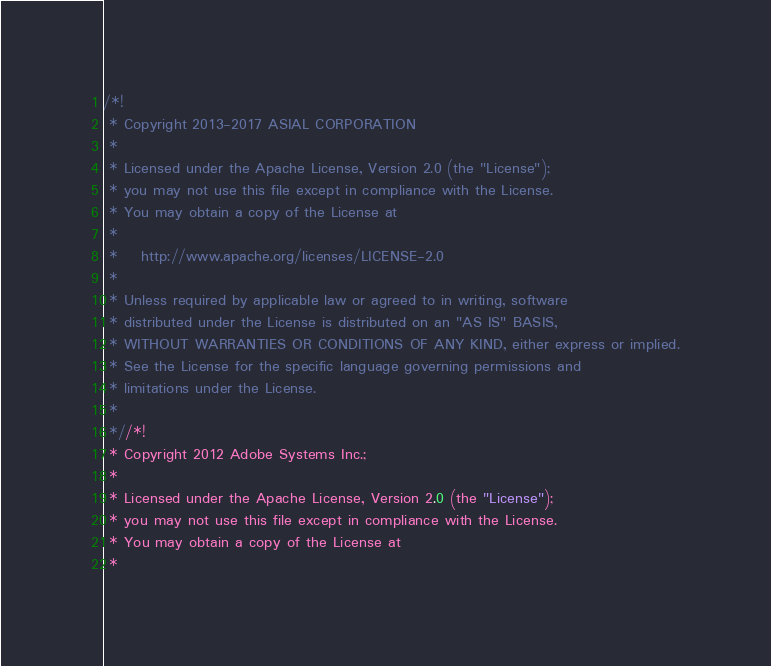<code> <loc_0><loc_0><loc_500><loc_500><_CSS_>/*!
 * Copyright 2013-2017 ASIAL CORPORATION
 *
 * Licensed under the Apache License, Version 2.0 (the "License");
 * you may not use this file except in compliance with the License.
 * You may obtain a copy of the License at
 *
 *    http://www.apache.org/licenses/LICENSE-2.0
 *
 * Unless required by applicable law or agreed to in writing, software
 * distributed under the License is distributed on an "AS IS" BASIS,
 * WITHOUT WARRANTIES OR CONDITIONS OF ANY KIND, either express or implied.
 * See the License for the specific language governing permissions and
 * limitations under the License.
 *
 *//*!
 * Copyright 2012 Adobe Systems Inc.;
 *
 * Licensed under the Apache License, Version 2.0 (the "License");
 * you may not use this file except in compliance with the License.
 * You may obtain a copy of the License at
 *</code> 